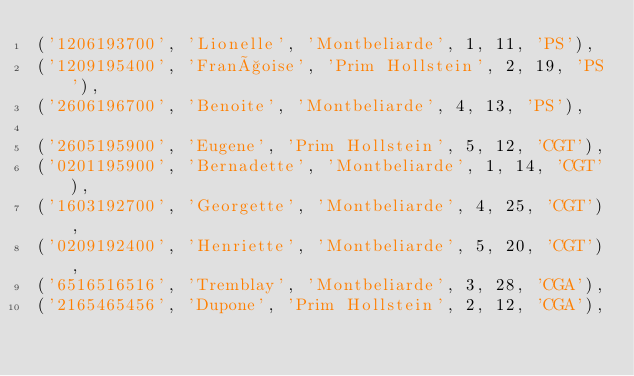Convert code to text. <code><loc_0><loc_0><loc_500><loc_500><_SQL_>('1206193700', 'Lionelle', 'Montbeliarde', 1, 11, 'PS'),
('1209195400', 'Françoise', 'Prim Hollstein', 2, 19, 'PS'),
('2606196700', 'Benoite', 'Montbeliarde', 4, 13, 'PS'),

('2605195900', 'Eugene', 'Prim Hollstein', 5, 12, 'CGT'),
('0201195900', 'Bernadette', 'Montbeliarde', 1, 14, 'CGT'),
('1603192700', 'Georgette', 'Montbeliarde', 4, 25, 'CGT'),
('0209192400', 'Henriette', 'Montbeliarde', 5, 20, 'CGT'),
('6516516516', 'Tremblay', 'Montbeliarde', 3, 28, 'CGA'),
('2165465456', 'Dupone', 'Prim Hollstein', 2, 12, 'CGA'),</code> 